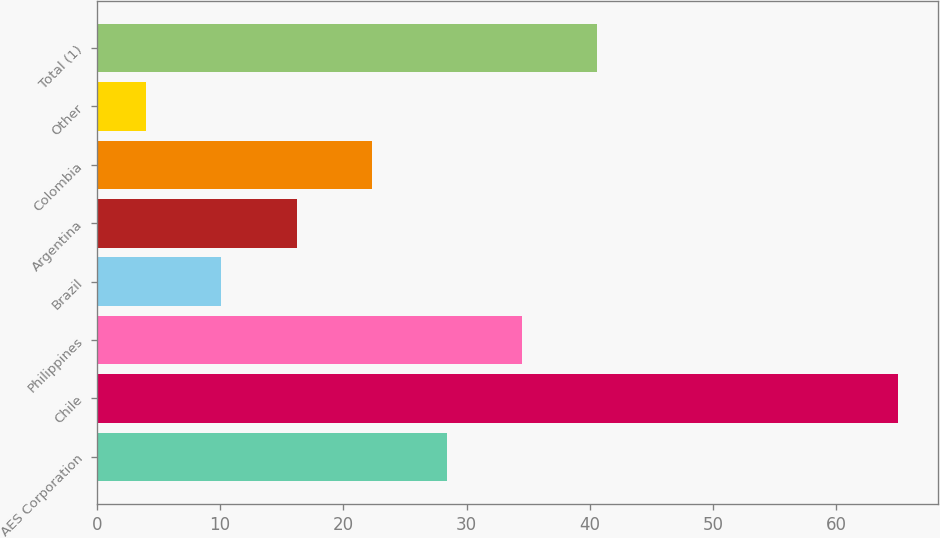Convert chart. <chart><loc_0><loc_0><loc_500><loc_500><bar_chart><fcel>AES Corporation<fcel>Chile<fcel>Philippines<fcel>Brazil<fcel>Argentina<fcel>Colombia<fcel>Other<fcel>Total (1)<nl><fcel>28.4<fcel>65<fcel>34.5<fcel>10.1<fcel>16.2<fcel>22.3<fcel>4<fcel>40.6<nl></chart> 